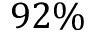Convert formula to latex. <formula><loc_0><loc_0><loc_500><loc_500>9 2 \%</formula> 